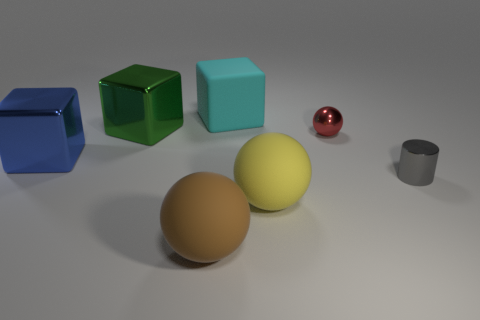How many other things are there of the same shape as the brown rubber object?
Give a very brief answer. 2. How many other things are made of the same material as the brown ball?
Your response must be concise. 2. What is the size of the red metal thing that is the same shape as the yellow matte thing?
Provide a succinct answer. Small. Is the color of the big matte cube the same as the shiny sphere?
Provide a short and direct response. No. There is a shiny object that is in front of the tiny ball and on the left side of the red ball; what color is it?
Make the answer very short. Blue. What number of things are large matte objects behind the big green metal object or tiny red cubes?
Your response must be concise. 1. What color is the big matte object that is the same shape as the big blue metallic object?
Offer a very short reply. Cyan. Does the large blue object have the same shape as the small shiny thing in front of the red object?
Your answer should be compact. No. What number of things are things that are right of the large green metal cube or small objects that are left of the cylinder?
Offer a very short reply. 5. Are there fewer big rubber objects behind the large yellow object than blue things?
Give a very brief answer. No. 